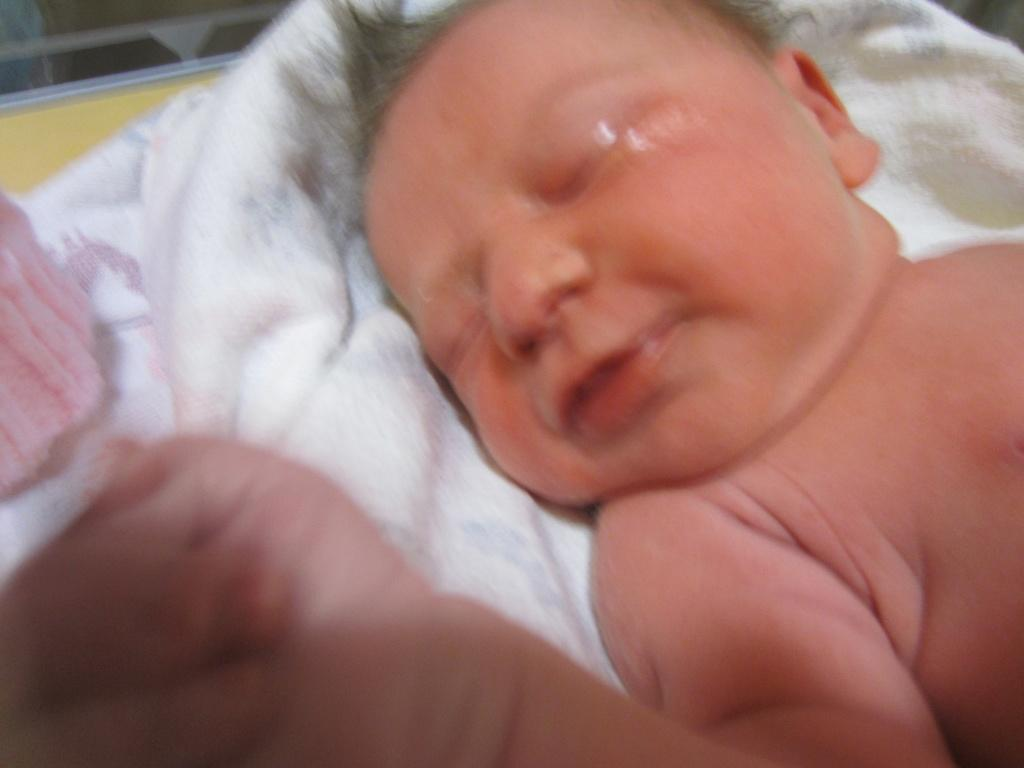What is the main subject of the image? The main subject of the image is a baby. What is the baby lying on? The baby is lying on a white colored cloth. How many rings are visible on the baby's fingers in the image? There are no rings visible on the baby's fingers in the image. What is the cause of death for the baby in the image? There is no indication of death in the image, as the baby is lying on a white colored cloth. 